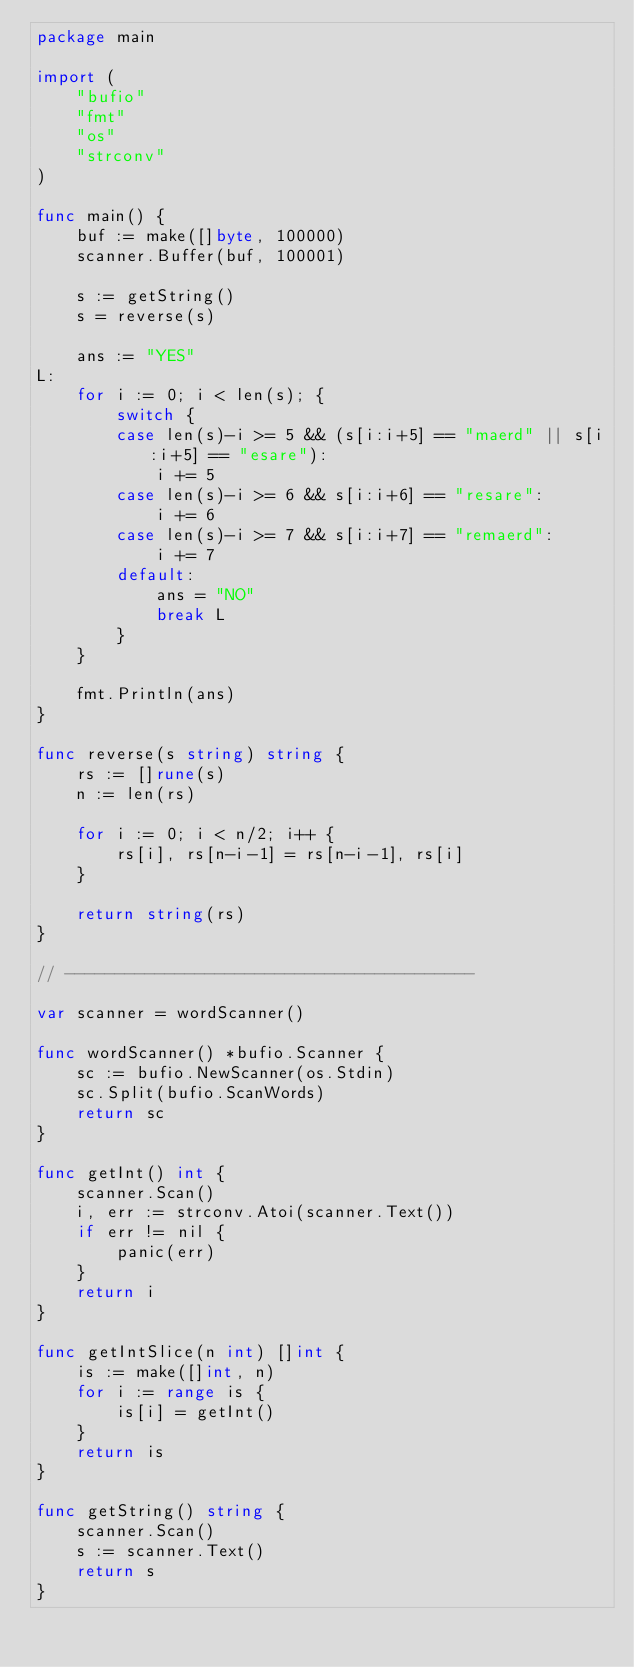Convert code to text. <code><loc_0><loc_0><loc_500><loc_500><_Go_>package main

import (
	"bufio"
	"fmt"
	"os"
	"strconv"
)

func main() {
	buf := make([]byte, 100000)
	scanner.Buffer(buf, 100001)

	s := getString()
	s = reverse(s)

	ans := "YES"
L:
	for i := 0; i < len(s); {
		switch {
		case len(s)-i >= 5 && (s[i:i+5] == "maerd" || s[i:i+5] == "esare"):
			i += 5
		case len(s)-i >= 6 && s[i:i+6] == "resare":
			i += 6
		case len(s)-i >= 7 && s[i:i+7] == "remaerd":
			i += 7
		default:
			ans = "NO"
			break L
		}
	}

	fmt.Println(ans)
}

func reverse(s string) string {
	rs := []rune(s)
	n := len(rs)

	for i := 0; i < n/2; i++ {
		rs[i], rs[n-i-1] = rs[n-i-1], rs[i]
	}

	return string(rs)
}

// -----------------------------------------

var scanner = wordScanner()

func wordScanner() *bufio.Scanner {
	sc := bufio.NewScanner(os.Stdin)
	sc.Split(bufio.ScanWords)
	return sc
}

func getInt() int {
	scanner.Scan()
	i, err := strconv.Atoi(scanner.Text())
	if err != nil {
		panic(err)
	}
	return i
}

func getIntSlice(n int) []int {
	is := make([]int, n)
	for i := range is {
		is[i] = getInt()
	}
	return is
}

func getString() string {
	scanner.Scan()
	s := scanner.Text()
	return s
}
</code> 